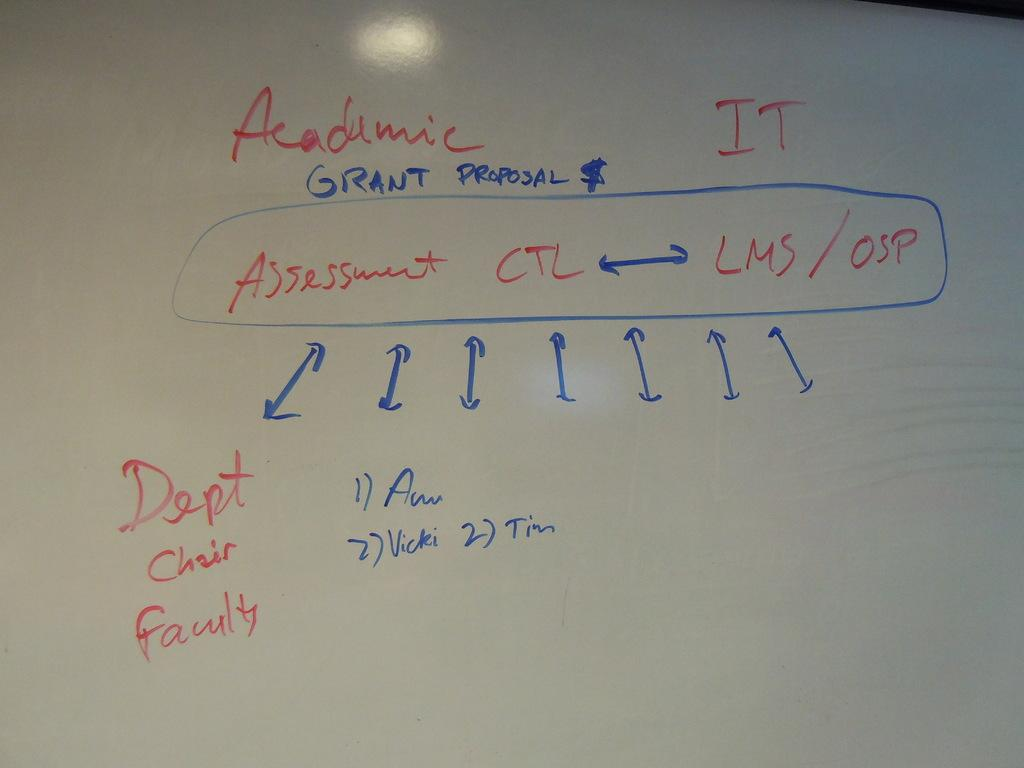<image>
Present a compact description of the photo's key features. A whiteboard outlining an academic grant proposal in red and blue marker. 